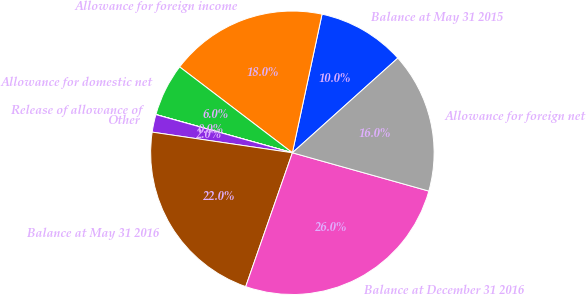Convert chart. <chart><loc_0><loc_0><loc_500><loc_500><pie_chart><fcel>Balance at May 31 2015<fcel>Allowance for foreign income<fcel>Allowance for domestic net<fcel>Release of allowance of<fcel>Other<fcel>Balance at May 31 2016<fcel>Balance at December 31 2016<fcel>Allowance for foreign net<nl><fcel>10.0%<fcel>18.0%<fcel>6.01%<fcel>0.01%<fcel>2.01%<fcel>21.99%<fcel>25.99%<fcel>16.0%<nl></chart> 